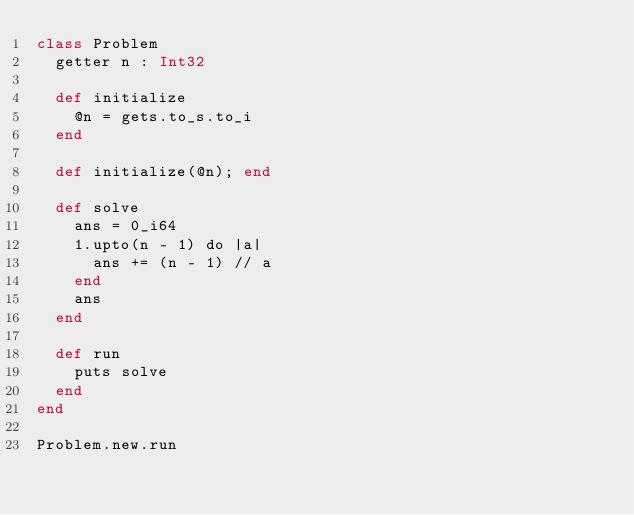Convert code to text. <code><loc_0><loc_0><loc_500><loc_500><_Crystal_>class Problem
  getter n : Int32

  def initialize
    @n = gets.to_s.to_i
  end

  def initialize(@n); end

  def solve
    ans = 0_i64
    1.upto(n - 1) do |a|
      ans += (n - 1) // a
    end
    ans
  end

  def run
    puts solve
  end
end

Problem.new.run</code> 